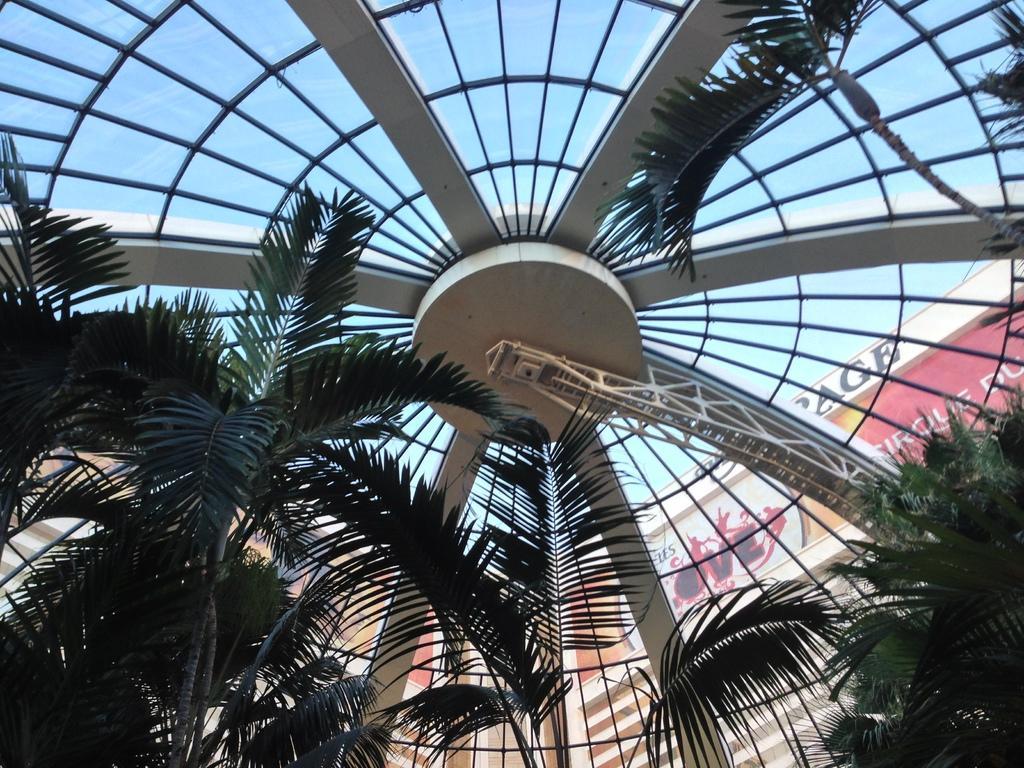Can you describe this image briefly? This picture shows buildings and we see trees. 